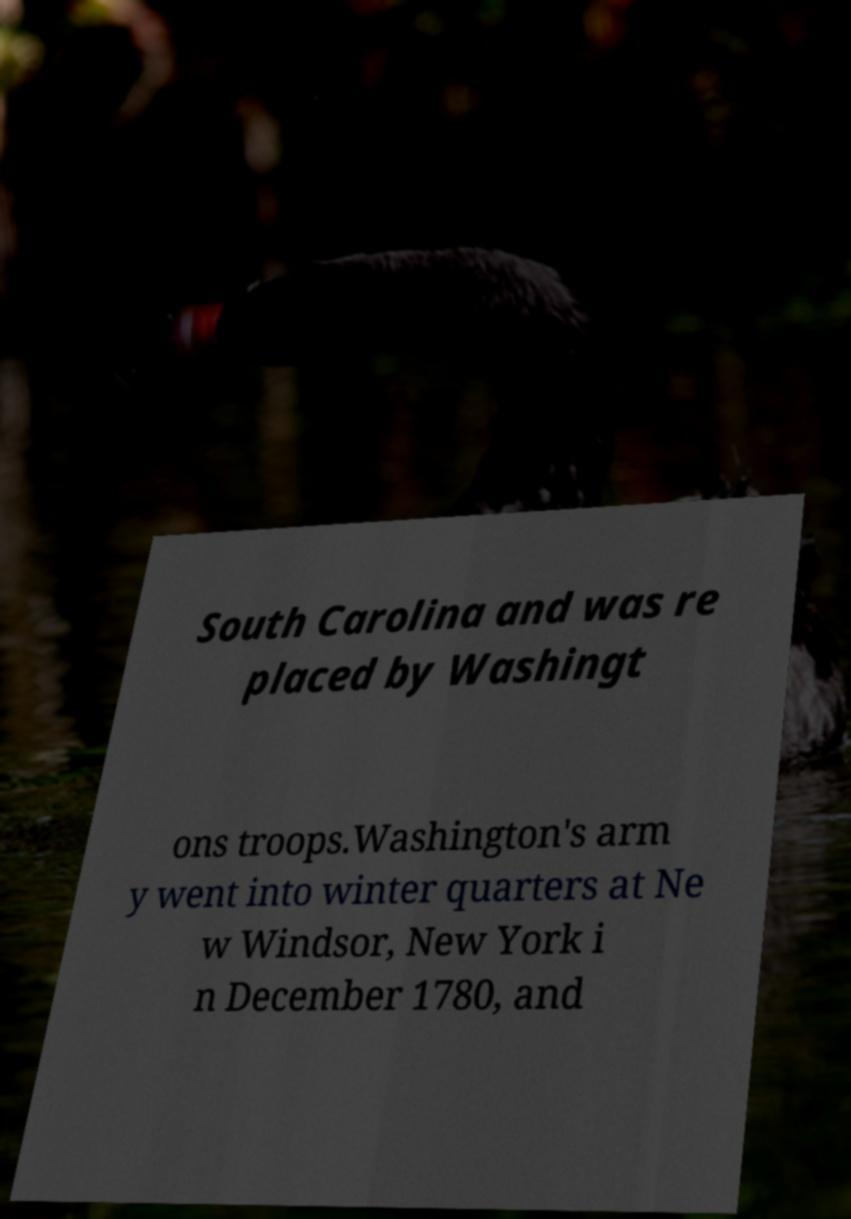Please read and relay the text visible in this image. What does it say? South Carolina and was re placed by Washingt ons troops.Washington's arm y went into winter quarters at Ne w Windsor, New York i n December 1780, and 